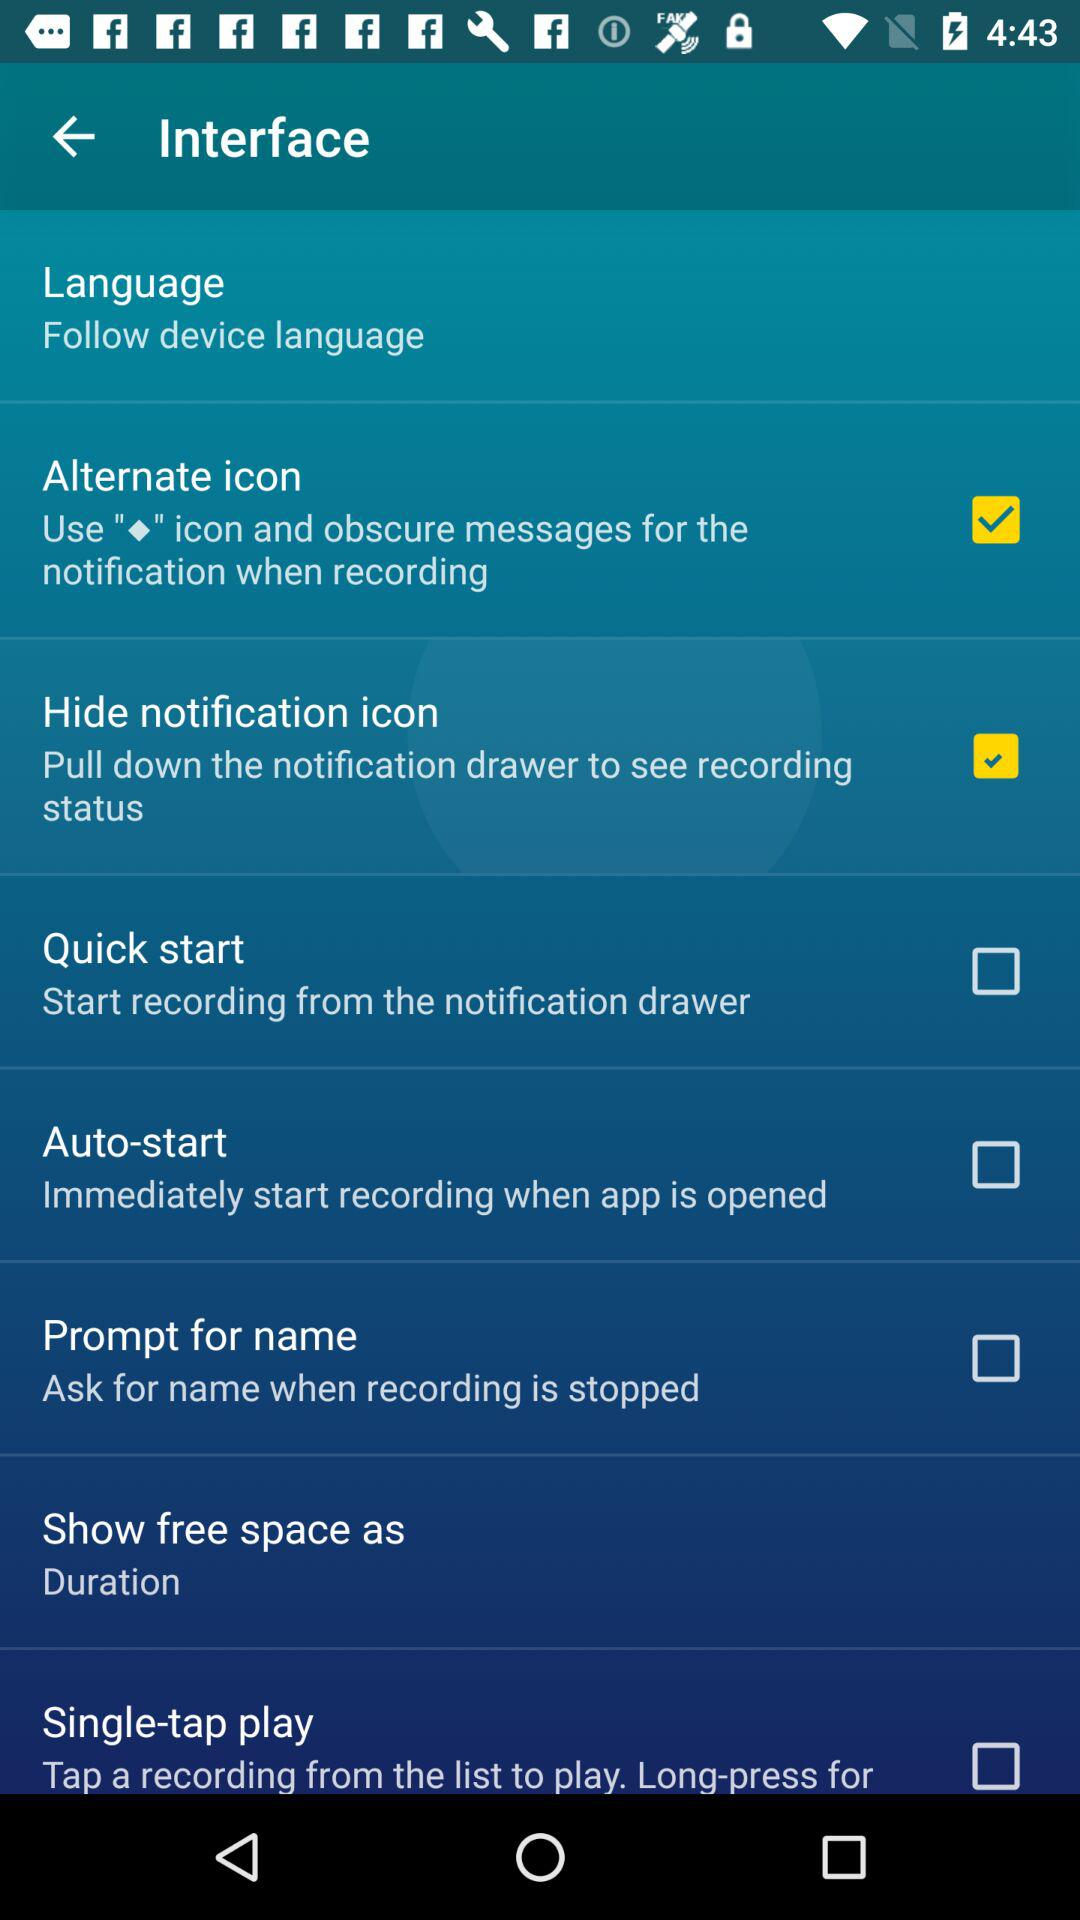What is the status of "Quick start"? The status is "off". 